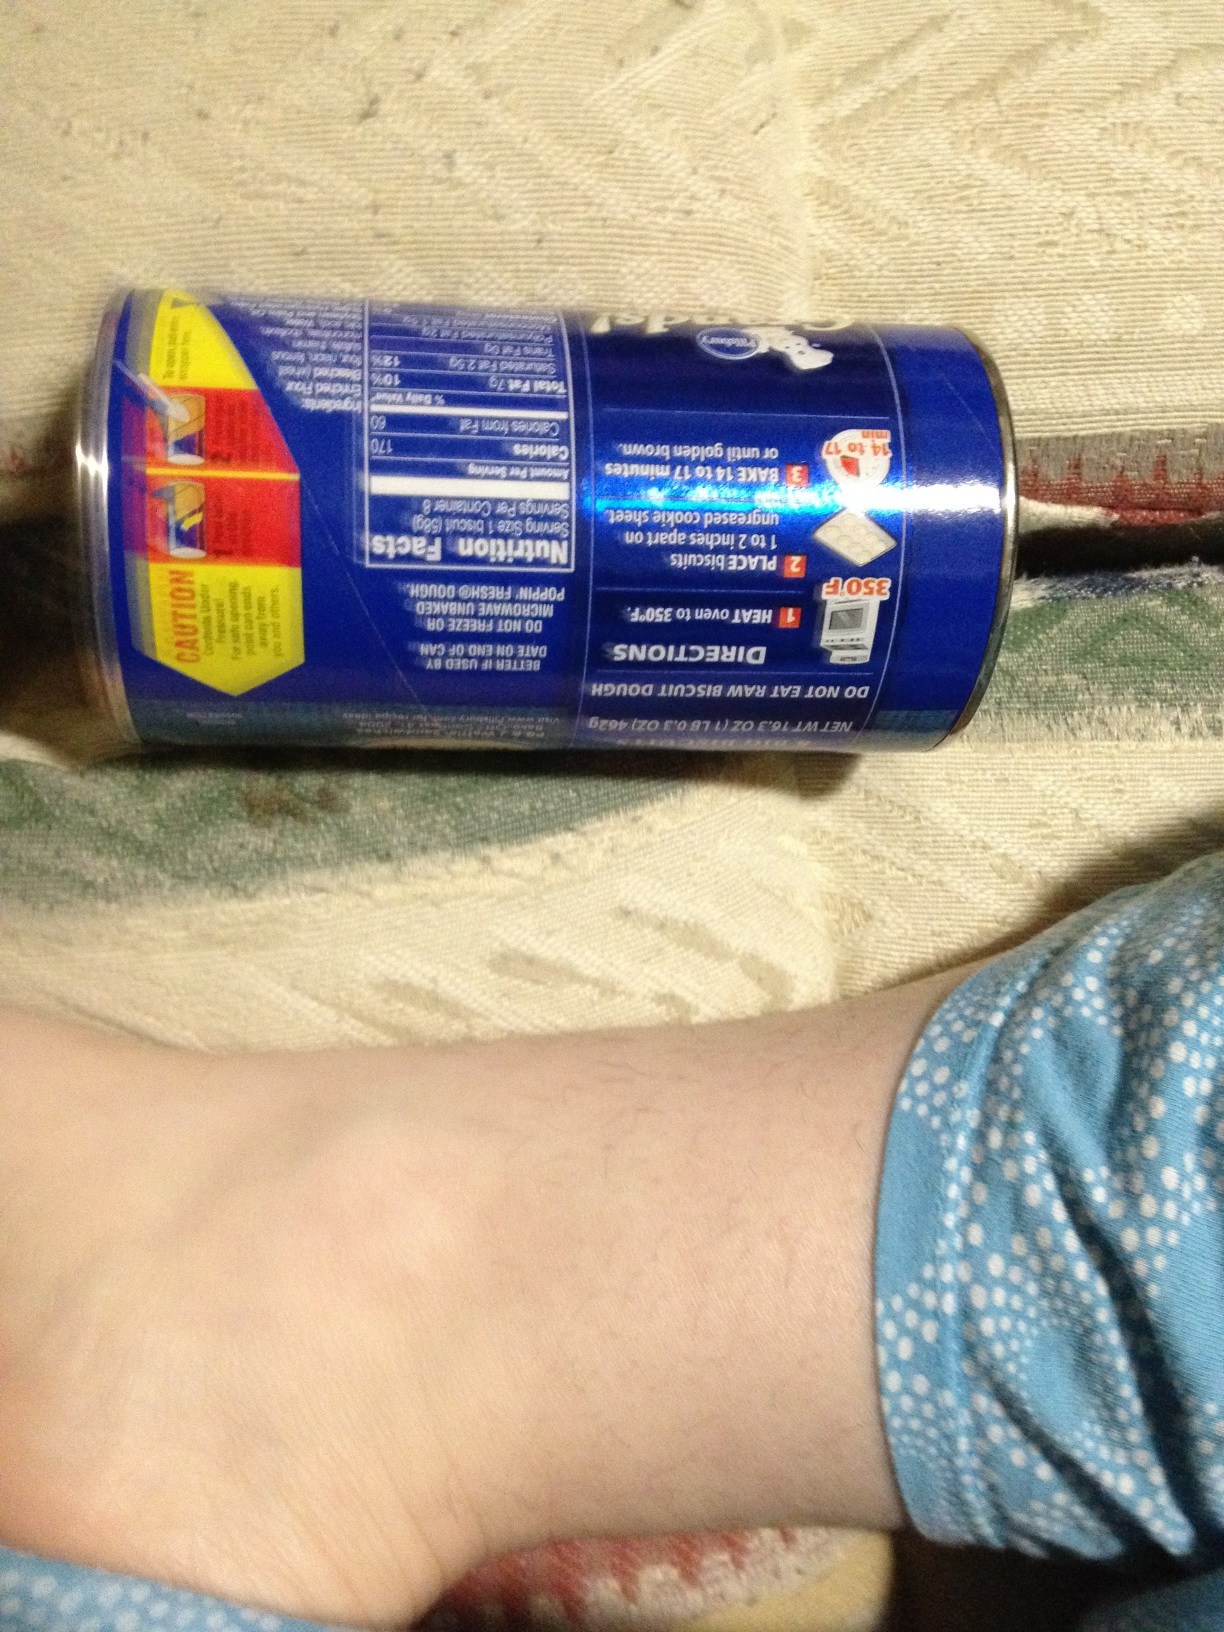Based on the image, what instructions are given to bake these biscuits? The baking instructions on the can suggest preheating the oven to 350°F. Place biscuits on an ungreased cookie sheet and bake for 14-17 minutes or until golden brown. Remove from oven and let cool slightly before serving. 